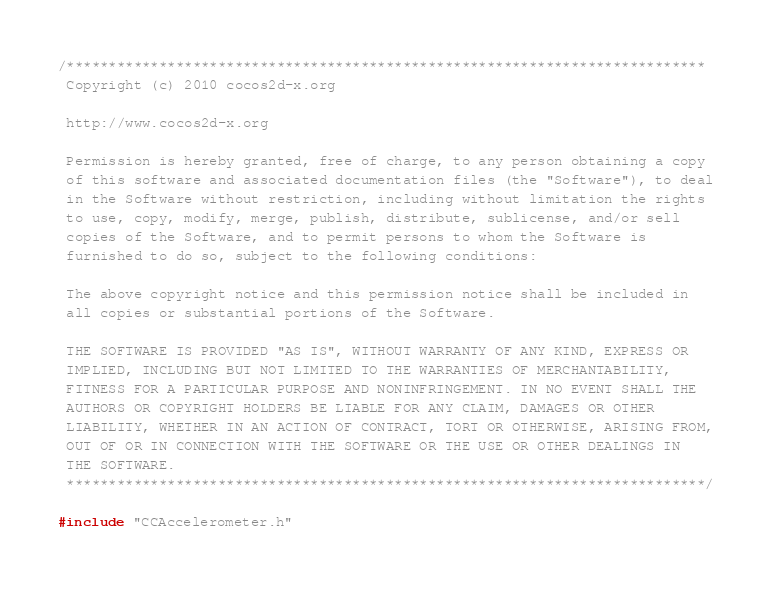<code> <loc_0><loc_0><loc_500><loc_500><_ObjectiveC_>/****************************************************************************
 Copyright (c) 2010 cocos2d-x.org
 
 http://www.cocos2d-x.org
 
 Permission is hereby granted, free of charge, to any person obtaining a copy
 of this software and associated documentation files (the "Software"), to deal
 in the Software without restriction, including without limitation the rights
 to use, copy, modify, merge, publish, distribute, sublicense, and/or sell
 copies of the Software, and to permit persons to whom the Software is
 furnished to do so, subject to the following conditions:
 
 The above copyright notice and this permission notice shall be included in
 all copies or substantial portions of the Software.
 
 THE SOFTWARE IS PROVIDED "AS IS", WITHOUT WARRANTY OF ANY KIND, EXPRESS OR
 IMPLIED, INCLUDING BUT NOT LIMITED TO THE WARRANTIES OF MERCHANTABILITY,
 FITNESS FOR A PARTICULAR PURPOSE AND NONINFRINGEMENT. IN NO EVENT SHALL THE
 AUTHORS OR COPYRIGHT HOLDERS BE LIABLE FOR ANY CLAIM, DAMAGES OR OTHER
 LIABILITY, WHETHER IN AN ACTION OF CONTRACT, TORT OR OTHERWISE, ARISING FROM,
 OUT OF OR IN CONNECTION WITH THE SOFTWARE OR THE USE OR OTHER DEALINGS IN
 THE SOFTWARE.
 ****************************************************************************/

#include "CCAccelerometer.h"</code> 